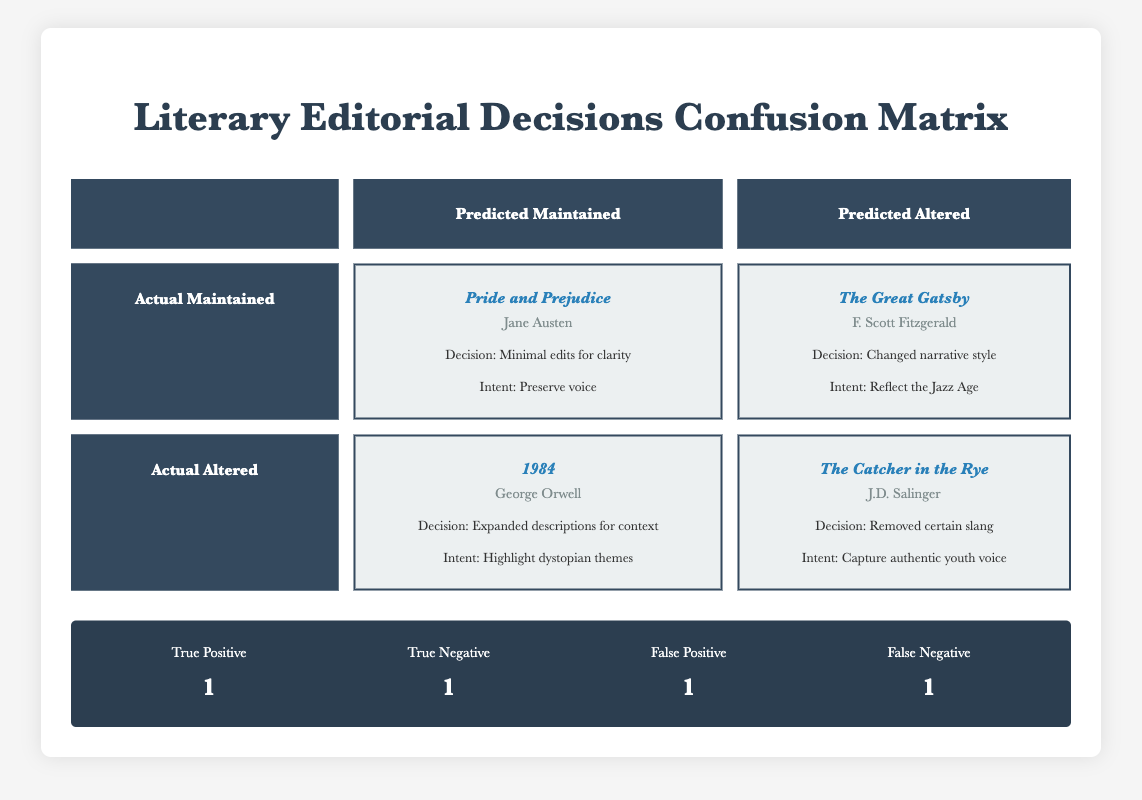What is the editorial decision for "Pride and Prejudice"? The table lists "Minimal edits for clarity" as the editorial decision for "Pride and Prejudice."
Answer: Minimal edits for clarity Which book was predicted to be maintained but was actually altered? The table includes "The Great Gatsby," which has "Changed narrative style" as an editorial decision, whereas it is placed under the predicted category of altered.
Answer: The Great Gatsby How many true positives are indicated in the confusion matrix? The summary section of the table specifies "True Positive" as 1.
Answer: 1 What is the editorial decision made for "1984"? The table shows that the editorial decision for "1984" was "Expanded descriptions for context."
Answer: Expanded descriptions for context For both "Pride and Prejudice" and "The Catcher in the Rye," how many editorial decisions were aimed at maintaining authorial intent? "Pride and Prejudice" aims to "Preserve voice," and "The Catcher in the Rye" primarily seeks to "Capture authentic youth voice," but only "Pride and Prejudice" fits the maintainer intention. So, there is only 1 decision that aligns with maintaining authorial intent.
Answer: 1 Is it true that all editorial decisions that maintained authorial intent were predicted accurately? "Pride and Prejudice" was accurately predicted to be maintained, but there was a false prediction for "The Catcher in the Rye," which does not preserve authorial intent. Therefore, it is false to say that all were predicted accurately.
Answer: No If we sum the true positives and true negatives, what is the total? The summary indicates "True Positive" as 1 and "True Negative" as 1. Adding these gives us a total of 1 + 1 = 2.
Answer: 2 Which author does "The Great Gatsby" belong to, and what was the editorial decision made for it? The table identifies "F. Scott Fitzgerald" as the author of "The Great Gatsby," and the editorial decision made for it was "Changed narrative style."
Answer: F. Scott Fitzgerald; Changed narrative style Was there a false negative in the confusion matrix, and what does it imply? Yes, there is a false negative indicated as 1 in the summary. This implies that one work that was altered was incorrectly predicted to maintain authorial intent, suggesting a misalignment in editorial assessment versus actual authorial goals.
Answer: Yes 